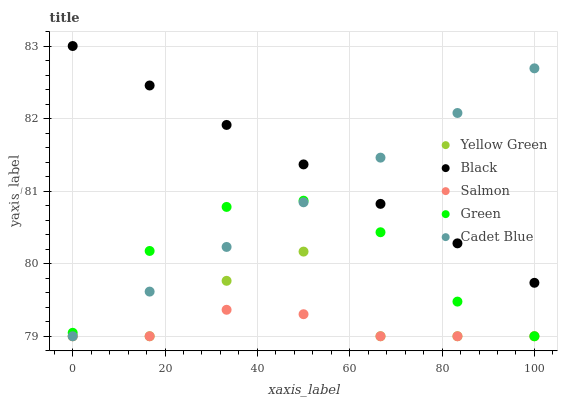Does Salmon have the minimum area under the curve?
Answer yes or no. Yes. Does Black have the maximum area under the curve?
Answer yes or no. Yes. Does Green have the minimum area under the curve?
Answer yes or no. No. Does Green have the maximum area under the curve?
Answer yes or no. No. Is Cadet Blue the smoothest?
Answer yes or no. Yes. Is Yellow Green the roughest?
Answer yes or no. Yes. Is Salmon the smoothest?
Answer yes or no. No. Is Salmon the roughest?
Answer yes or no. No. Does Cadet Blue have the lowest value?
Answer yes or no. Yes. Does Black have the lowest value?
Answer yes or no. No. Does Black have the highest value?
Answer yes or no. Yes. Does Green have the highest value?
Answer yes or no. No. Is Green less than Black?
Answer yes or no. Yes. Is Black greater than Salmon?
Answer yes or no. Yes. Does Yellow Green intersect Green?
Answer yes or no. Yes. Is Yellow Green less than Green?
Answer yes or no. No. Is Yellow Green greater than Green?
Answer yes or no. No. Does Green intersect Black?
Answer yes or no. No. 